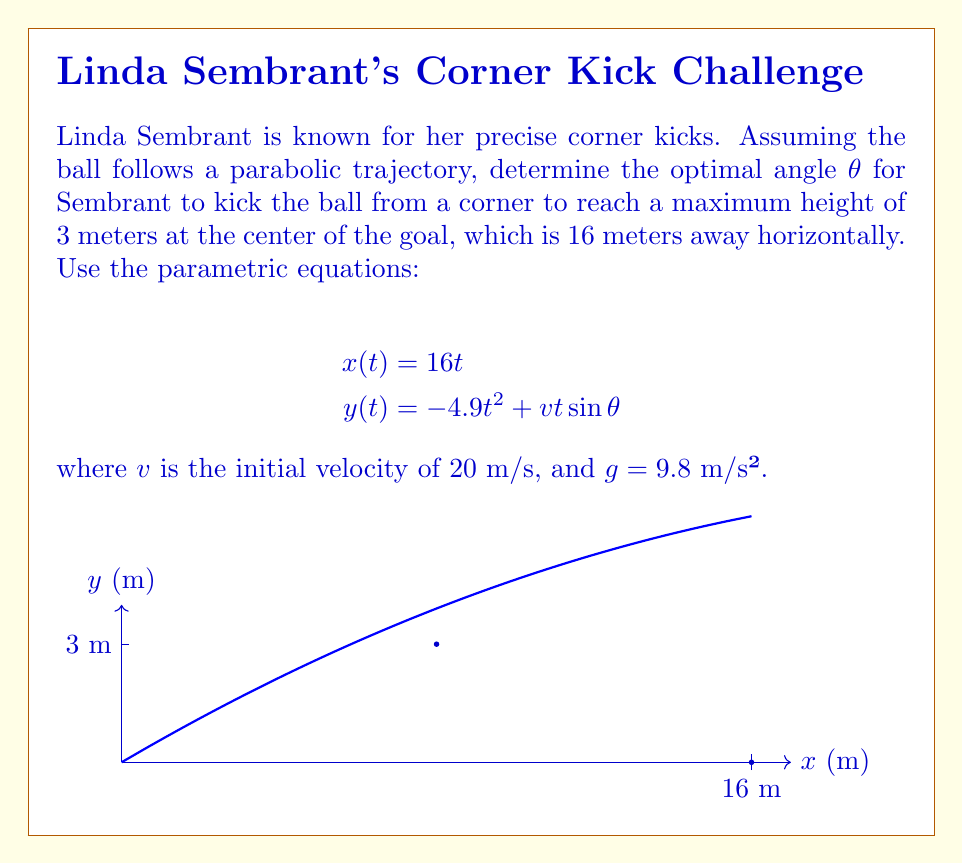Show me your answer to this math problem. To solve this problem, we'll follow these steps:

1) We know that the ball reaches its maximum height at the center of the goal, which is 8 meters horizontally from the corner. At this point, t = 0.5 seconds (since x = 16t and x = 8 when t = 0.5).

2) Substitute t = 0.5 and y = 3 into the y(t) equation:

   $$3 = -4.9(0.5)^2 + 20(0.5)\sin θ$$

3) Simplify:
   
   $$3 = -1.225 + 10\sin θ$$

4) Solve for sin θ:

   $$10\sin θ = 4.225$$
   $$\sin θ = 0.4225$$

5) Take the inverse sine (arcsin) of both sides:

   $$θ = \arcsin(0.4225)$$

6) Calculate the result:

   $$θ ≈ 25.0°$$

This angle will ensure that the ball reaches a maximum height of 3 meters at the center of the goal, 8 meters away horizontally from the kick point.
Answer: $θ ≈ 25.0°$ 